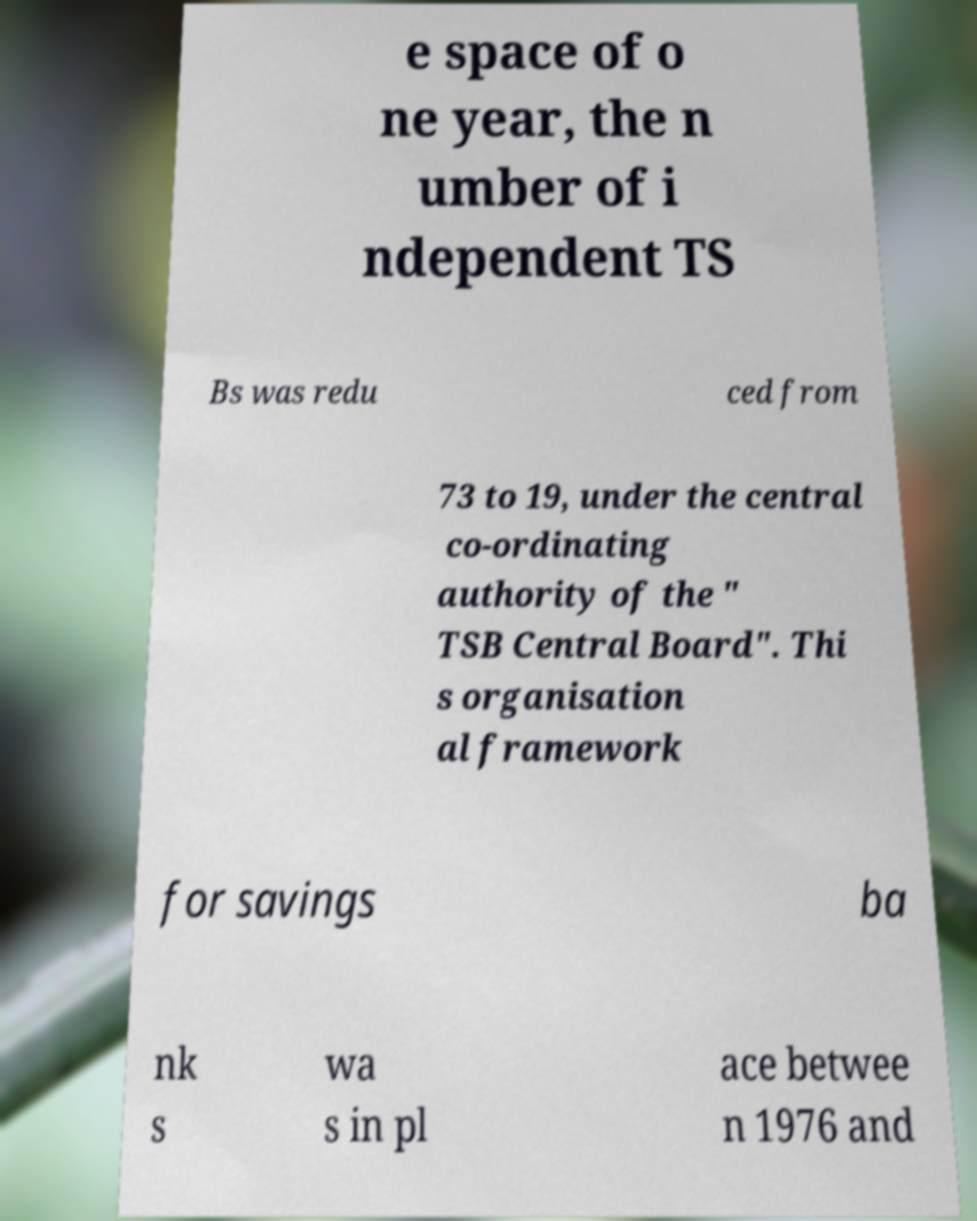I need the written content from this picture converted into text. Can you do that? e space of o ne year, the n umber of i ndependent TS Bs was redu ced from 73 to 19, under the central co-ordinating authority of the " TSB Central Board". Thi s organisation al framework for savings ba nk s wa s in pl ace betwee n 1976 and 